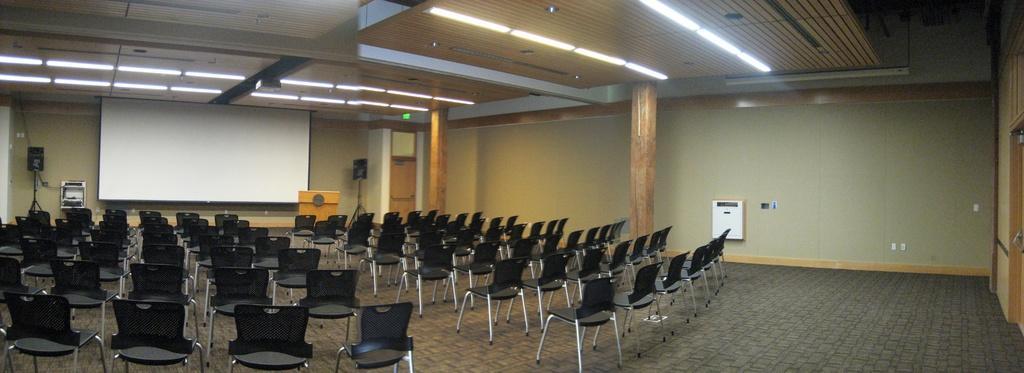Please provide a concise description of this image. This picture was taken inside an auditorium. These are the chairs. I can see a podium. This looks like a screen. I can see the speakers with the stands. These are the tube lights, which are attached to the ceiling. I can see the pillars. Here is a door. This looks like an object, which is attached to the wall. 